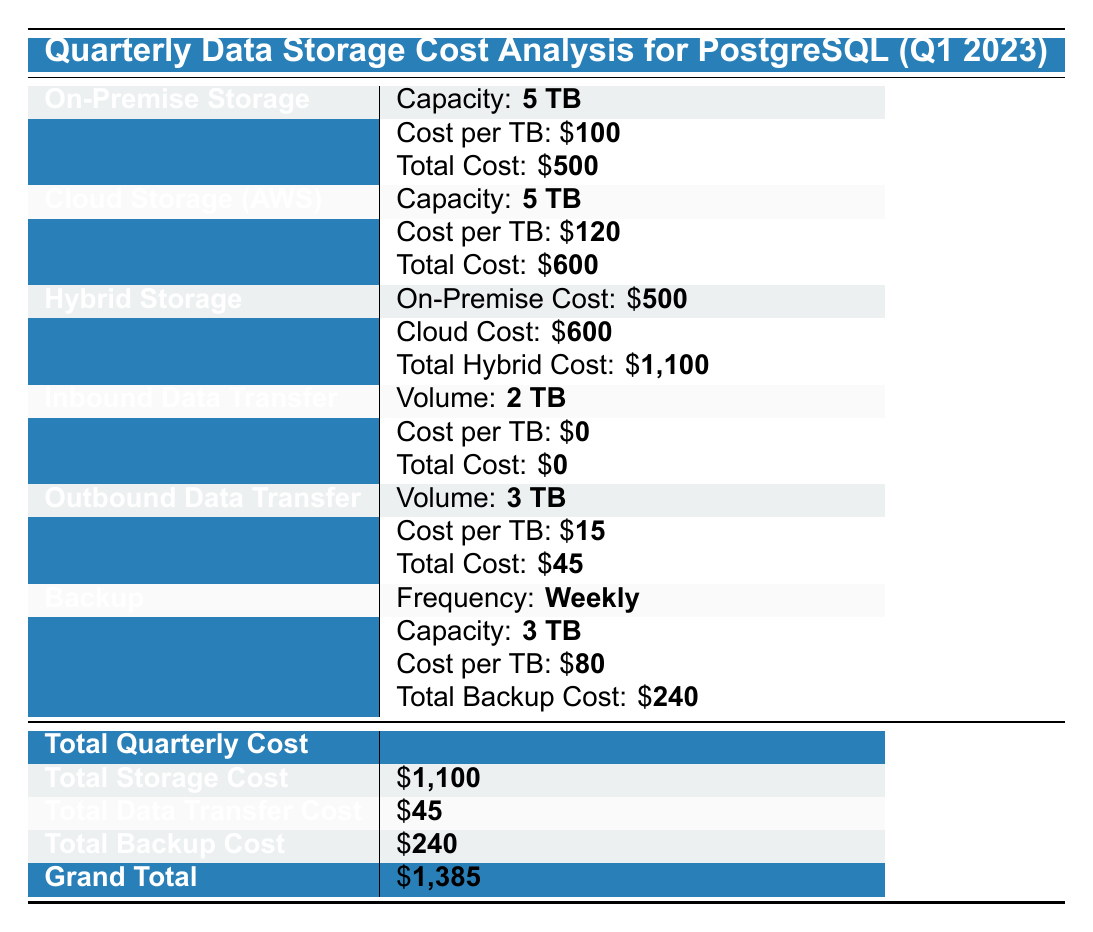What is the total cost for On-Premise storage? The table states that the total cost for On-Premise storage is clearly indicated as \$500.
Answer: 500 What is the cost per TB for Cloud storage? From the table, the cost per TB for Cloud storage is stated as \$120.
Answer: 120 How much does it cost to transfer 3 TB of data outbound? The total cost for outbound data transfer for 3 TB is shown as \$45 in the table.
Answer: 45 What is the total cost for backup services? The table specifies that the total backup cost is \$240.
Answer: 240 In which storage option does AWS fall under? The table indicates that AWS is classified under the Cloud storage category.
Answer: Cloud Is the cost per TB for On-Premise storage higher than that for backup storage? The cost per TB for On-Premise storage is \$100, while for backup storage it is \$80. Since \$100 is greater than \$80, the statement is true.
Answer: Yes What is the total hybrid storage cost? The total hybrid cost is computed as the sum of the On-Premise cost (\$500) and the Cloud cost (\$600), which totals \$1,100.
Answer: 1100 If an organization were to use all three storage options, what would their total cost be? The total cost for using On-Premise storage (\$500), Cloud storage (\$600), and Hybrid storage (\$1,100) is a bit misleading; the Hybrid cost already combines the other two, so just adding those directly would be incorrect. The hybrid total cost is \$1,100, thus they need only to consider that one.
Answer: 1100 What is the grand total cost for the quarter? The grand total cost is specifically indicated in the table as \$1,385.
Answer: 1385 If the organization only used Cloud storage, how much would they save compared to using Hybrid storage? Using Hybrid storage costs \$1,100, and using only Cloud storage costs \$600. The savings would be \$1,100 - \$600 = \$500.
Answer: 500 